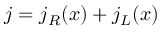<formula> <loc_0><loc_0><loc_500><loc_500>j = j _ { R } ( x ) + j _ { L } ( x )</formula> 